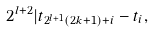Convert formula to latex. <formula><loc_0><loc_0><loc_500><loc_500>2 ^ { l + 2 } | t _ { 2 ^ { l + 1 } ( 2 k + 1 ) + i } - t _ { i } ,</formula> 